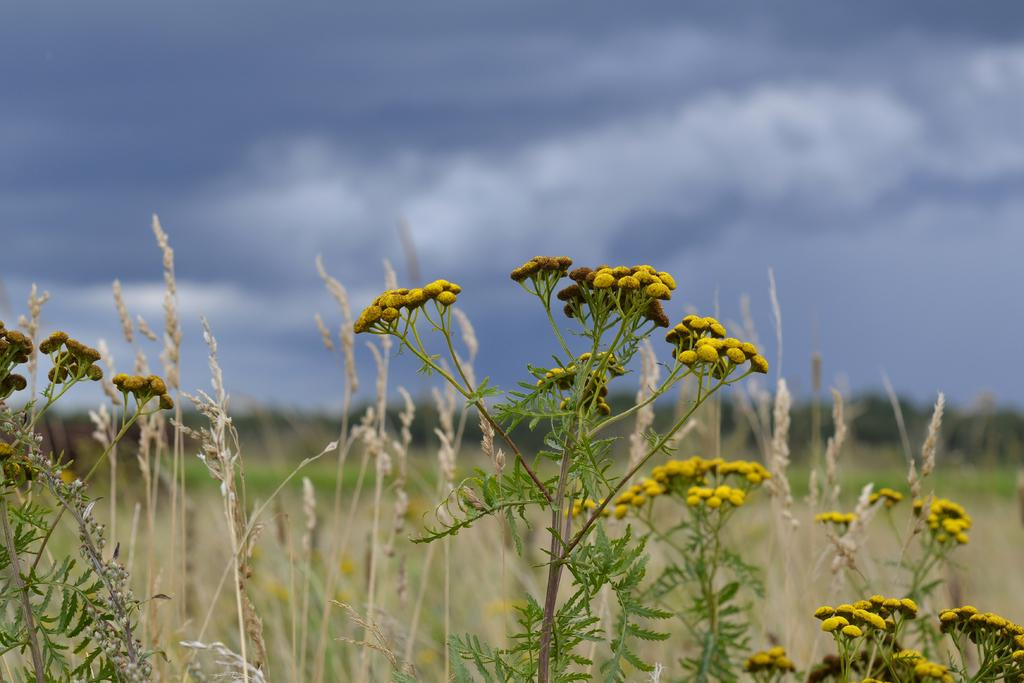What type of living organisms can be seen in the image? Plants can be seen in the image. Are there any specific flowers visible among the plants? Yes, there are yellow flowers in the image. What can be seen in the background of the image? The sky is visible in the background of the image. How would you describe the weather based on the appearance of the sky? The sky appears to be cloudy, which might suggest overcast or potentially rainy weather. How many pigs are visible in the image? There are no pigs present in the image; it features plants and yellow flowers with a cloudy sky in the background. 